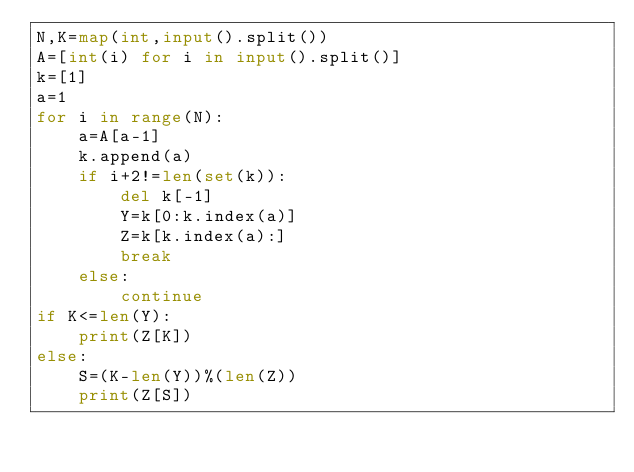<code> <loc_0><loc_0><loc_500><loc_500><_Python_>N,K=map(int,input().split())
A=[int(i) for i in input().split()]
k=[1]
a=1
for i in range(N):
    a=A[a-1]
    k.append(a)
    if i+2!=len(set(k)):
        del k[-1]
        Y=k[0:k.index(a)]
        Z=k[k.index(a):]
        break
    else:
        continue
if K<=len(Y):
    print(Z[K])
else:
    S=(K-len(Y))%(len(Z)) 
    print(Z[S])</code> 